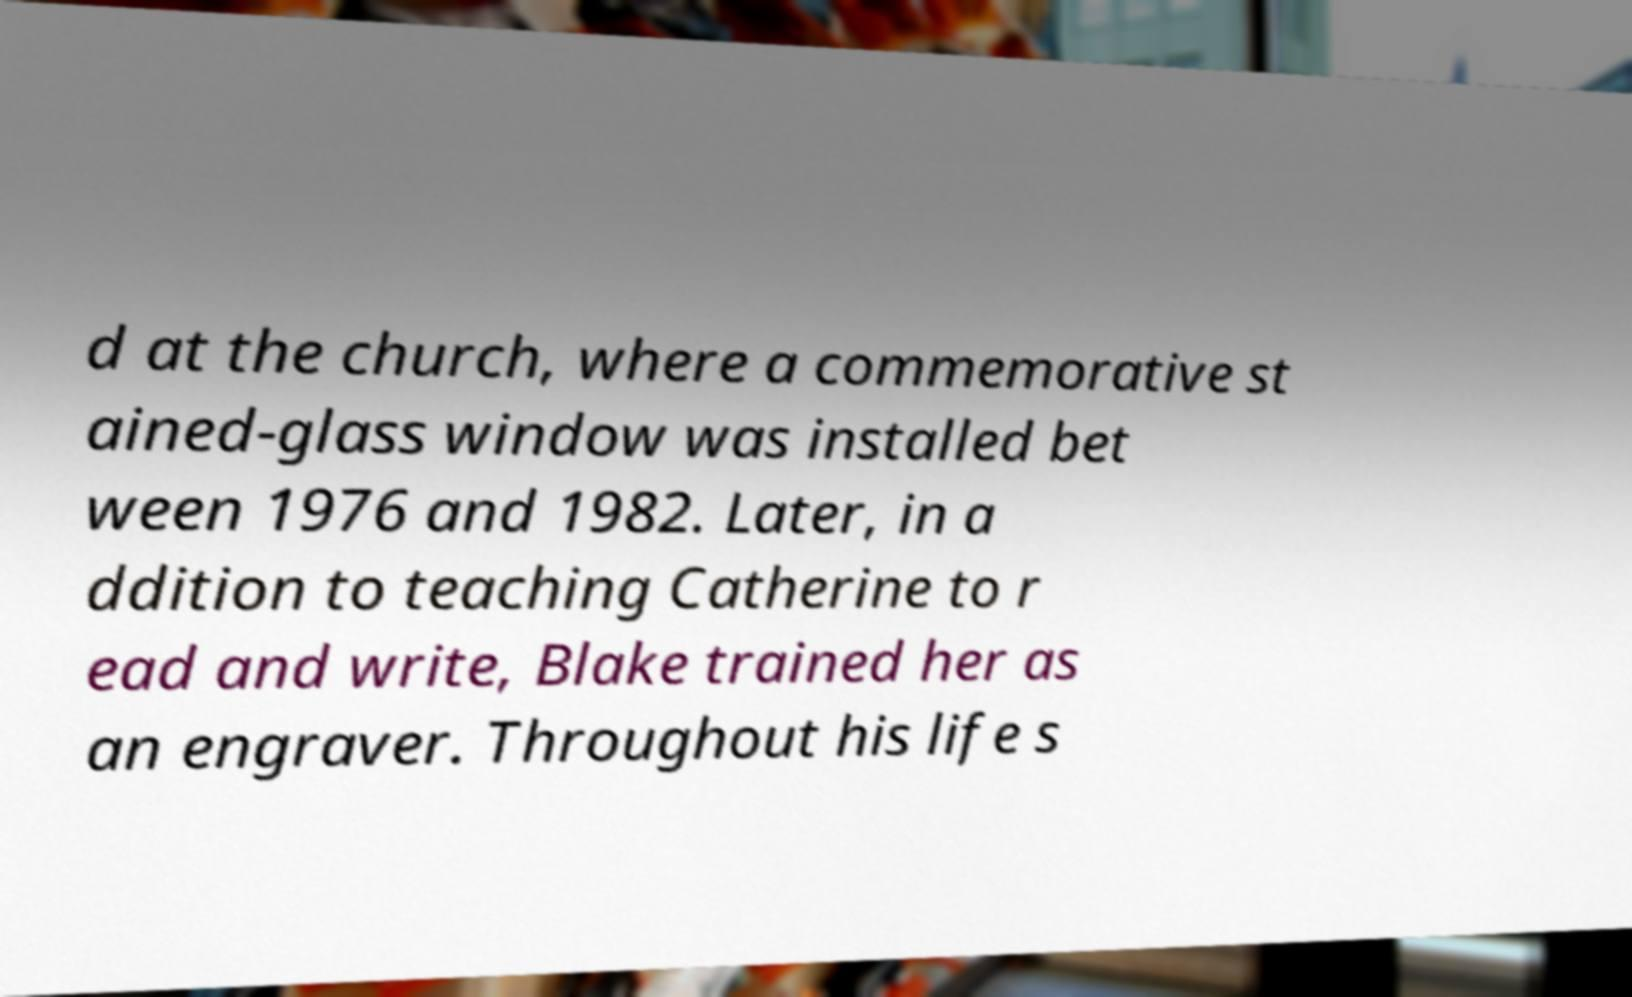Could you assist in decoding the text presented in this image and type it out clearly? d at the church, where a commemorative st ained-glass window was installed bet ween 1976 and 1982. Later, in a ddition to teaching Catherine to r ead and write, Blake trained her as an engraver. Throughout his life s 